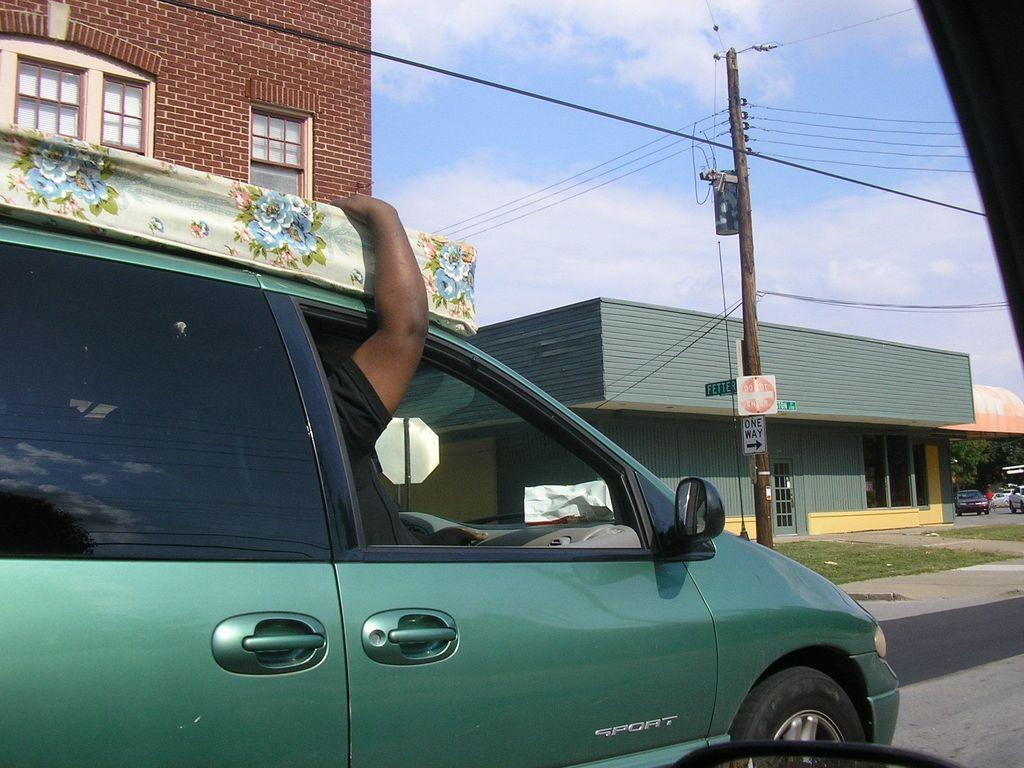What is the person in the image doing? There is a person riding a car in the image. Where is the car located? The car is on the road. What can be seen beside the road? There is an electrical pole beside the road. What else can be seen in the image? There are buildings visible in the image. Are there any other vehicles on the road? Yes, there are other cars on the road. What type of coat is the person wearing while operating the car in the image? There is no information about the person's clothing in the image, and the person is not operating the car, they are riding it. 